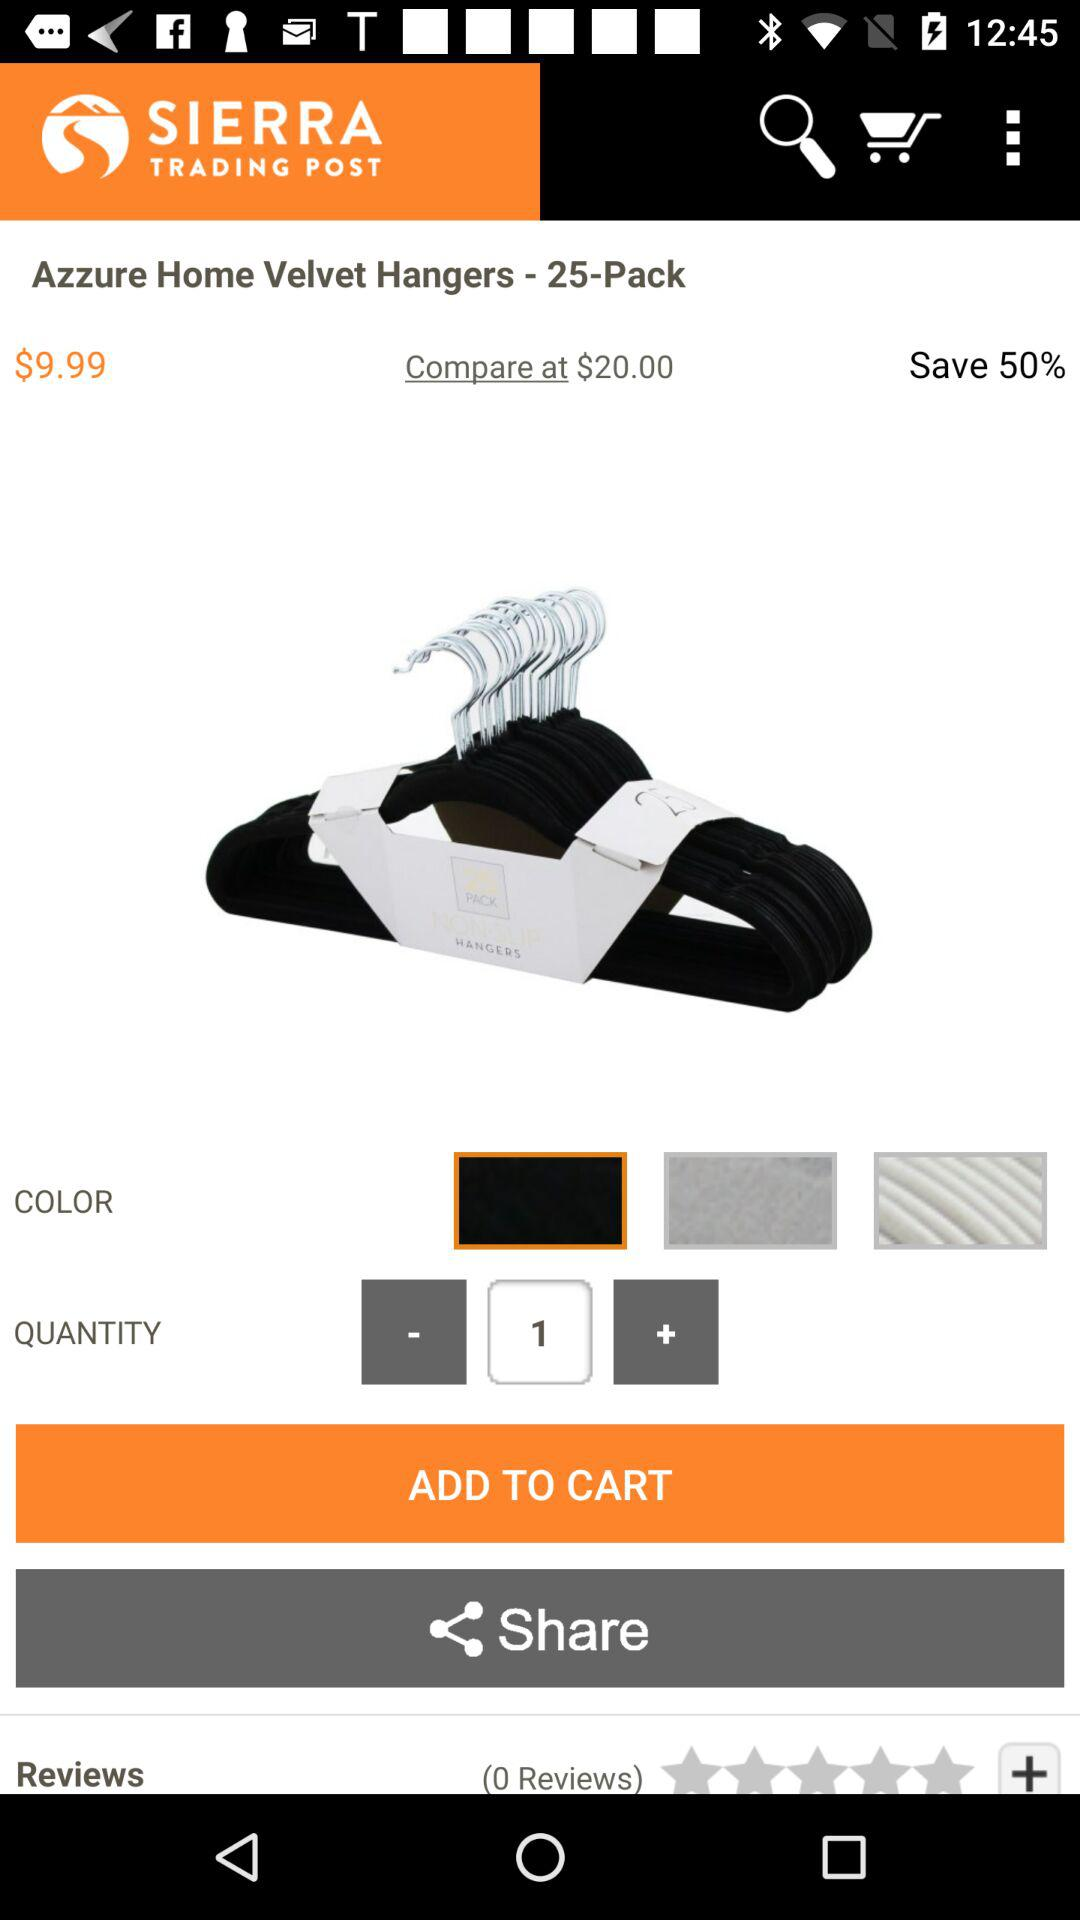What is the price of the product? The price of the product is $9.99. 